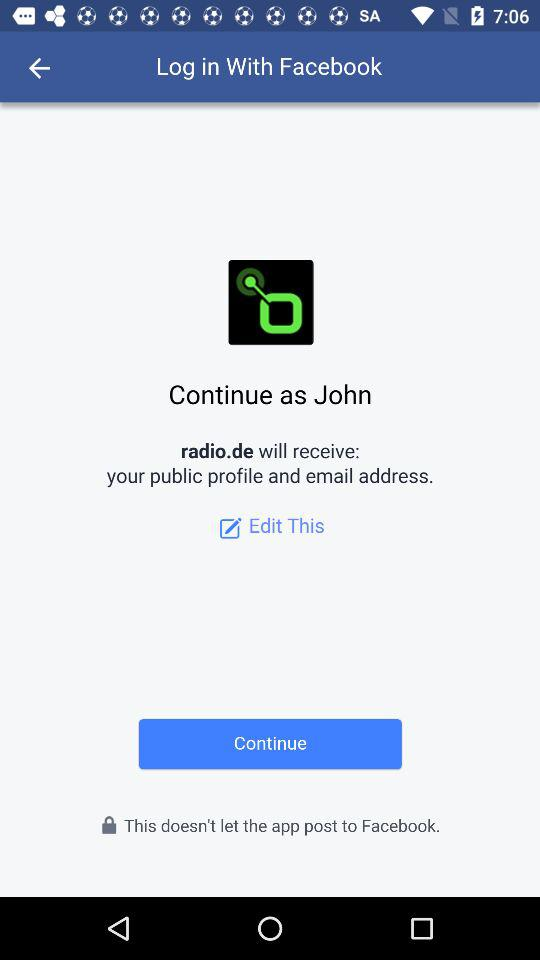When was the last time "John" logged in?
When the provided information is insufficient, respond with <no answer>. <no answer> 